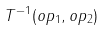Convert formula to latex. <formula><loc_0><loc_0><loc_500><loc_500>T ^ { - 1 } ( o p _ { 1 } , o p _ { 2 } )</formula> 